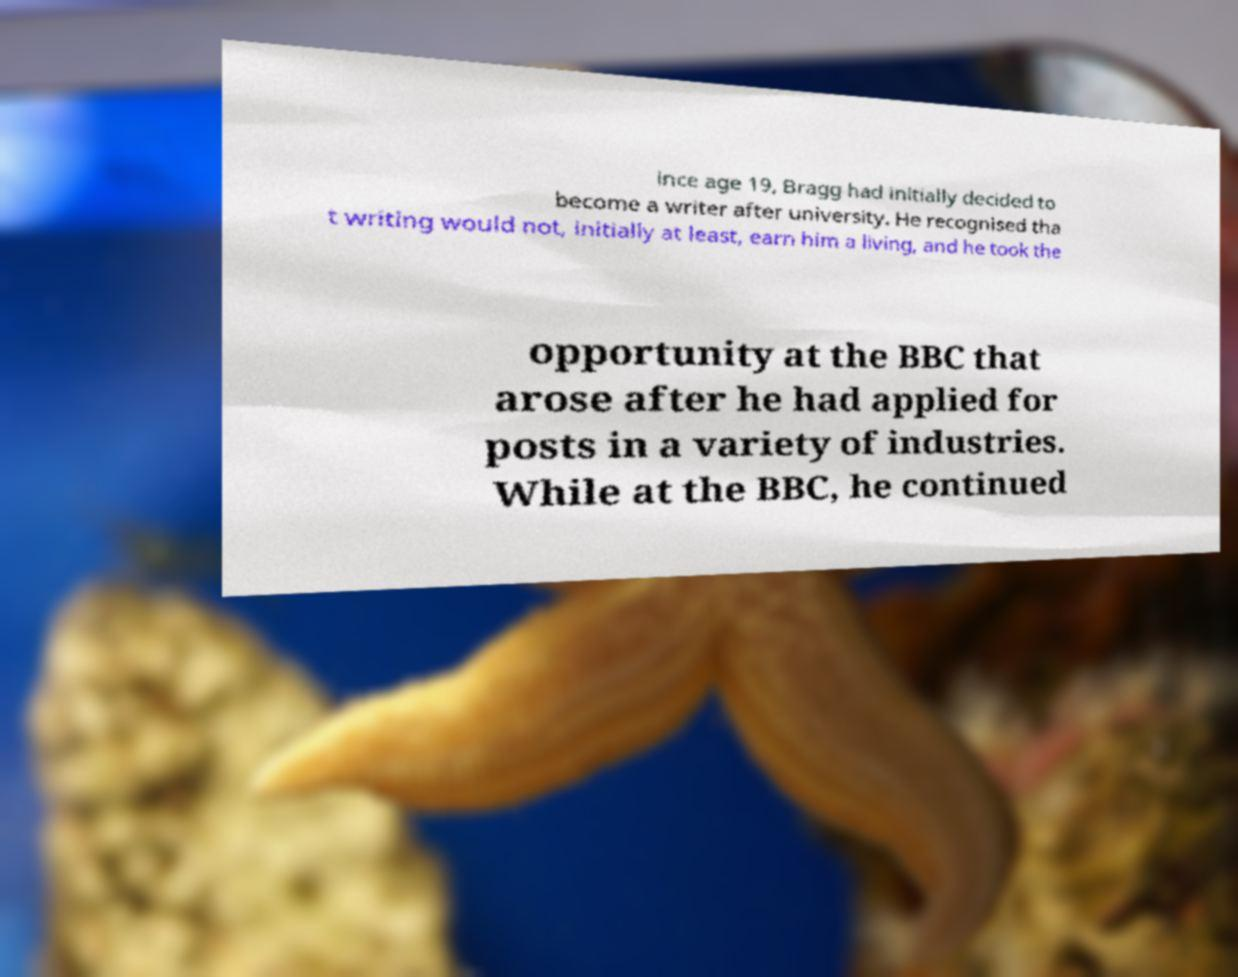Please identify and transcribe the text found in this image. ince age 19, Bragg had initially decided to become a writer after university. He recognised tha t writing would not, initially at least, earn him a living, and he took the opportunity at the BBC that arose after he had applied for posts in a variety of industries. While at the BBC, he continued 